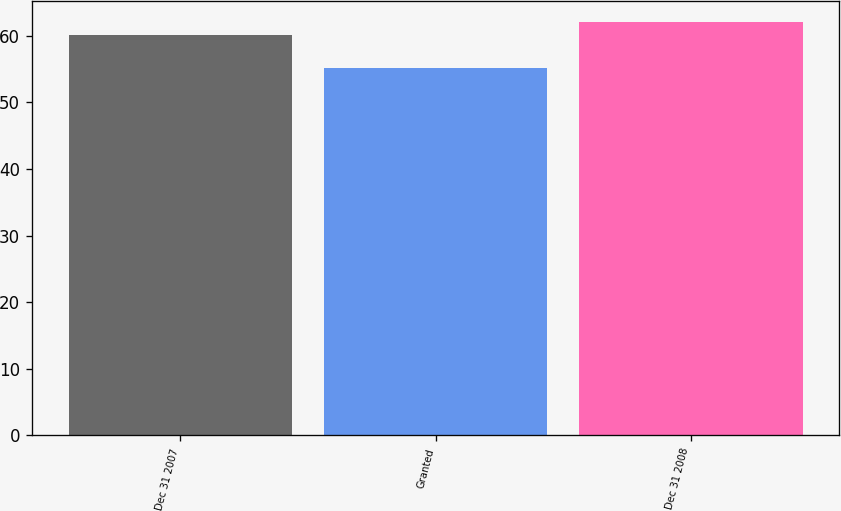<chart> <loc_0><loc_0><loc_500><loc_500><bar_chart><fcel>Dec 31 2007<fcel>Granted<fcel>Dec 31 2008<nl><fcel>60.2<fcel>55.2<fcel>62.07<nl></chart> 